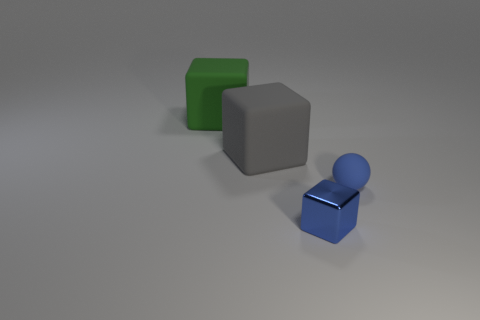Add 1 matte spheres. How many objects exist? 5 Subtract all spheres. How many objects are left? 3 Add 4 blue matte balls. How many blue matte balls exist? 5 Subtract 0 gray cylinders. How many objects are left? 4 Subtract all small cubes. Subtract all metallic things. How many objects are left? 2 Add 1 big objects. How many big objects are left? 3 